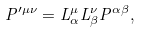Convert formula to latex. <formula><loc_0><loc_0><loc_500><loc_500>P ^ { \prime \mu \nu } = L ^ { \mu } _ { \alpha } L ^ { \nu } _ { \beta } P ^ { \alpha \beta } ,</formula> 